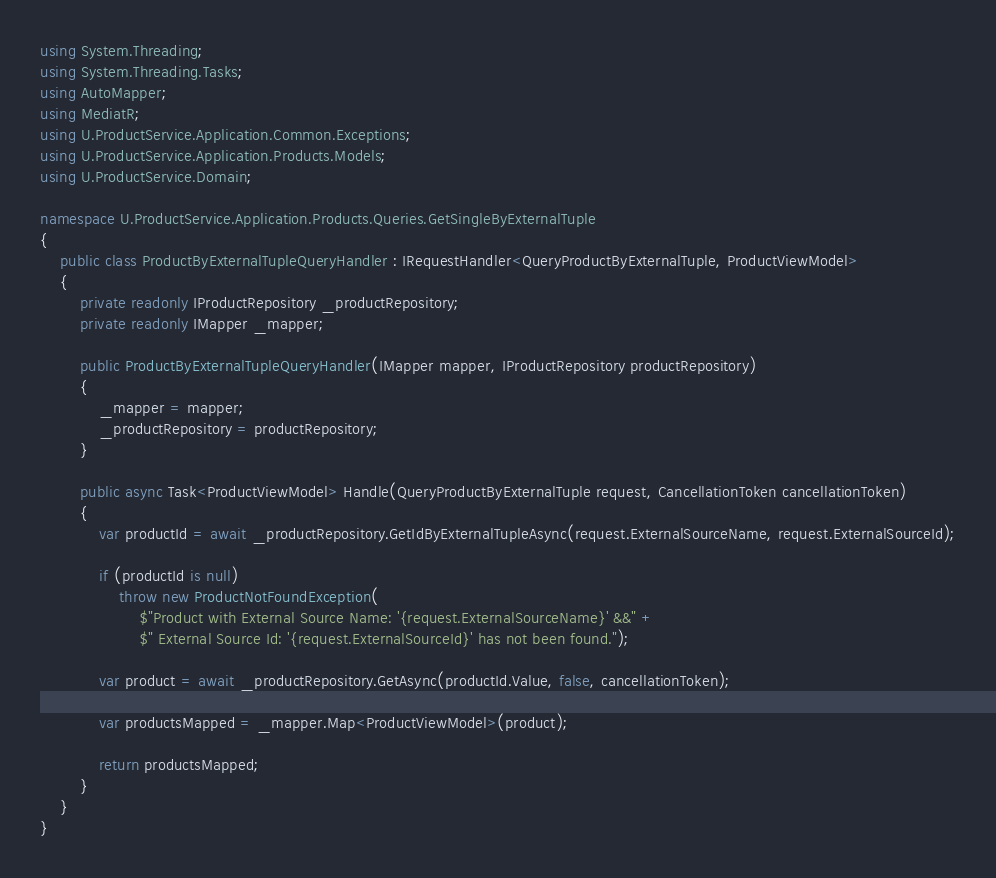<code> <loc_0><loc_0><loc_500><loc_500><_C#_>using System.Threading;
using System.Threading.Tasks;
using AutoMapper;
using MediatR;
using U.ProductService.Application.Common.Exceptions;
using U.ProductService.Application.Products.Models;
using U.ProductService.Domain;

namespace U.ProductService.Application.Products.Queries.GetSingleByExternalTuple
{
    public class ProductByExternalTupleQueryHandler : IRequestHandler<QueryProductByExternalTuple, ProductViewModel>
    {
        private readonly IProductRepository _productRepository;
        private readonly IMapper _mapper;

        public ProductByExternalTupleQueryHandler(IMapper mapper, IProductRepository productRepository)
        {
            _mapper = mapper;
            _productRepository = productRepository;
        }

        public async Task<ProductViewModel> Handle(QueryProductByExternalTuple request, CancellationToken cancellationToken)
        {
            var productId = await _productRepository.GetIdByExternalTupleAsync(request.ExternalSourceName, request.ExternalSourceId);

            if (productId is null)
                throw new ProductNotFoundException(
                    $"Product with External Source Name: '{request.ExternalSourceName}' &&" +
                    $" External Source Id: '{request.ExternalSourceId}' has not been found.");

            var product = await _productRepository.GetAsync(productId.Value, false, cancellationToken);

            var productsMapped = _mapper.Map<ProductViewModel>(product);

            return productsMapped;
        }
    }
}</code> 